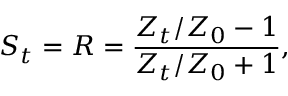<formula> <loc_0><loc_0><loc_500><loc_500>S _ { t } = R = \frac { Z _ { t } / Z _ { 0 } - 1 } { Z _ { t } / Z _ { 0 } + 1 } ,</formula> 